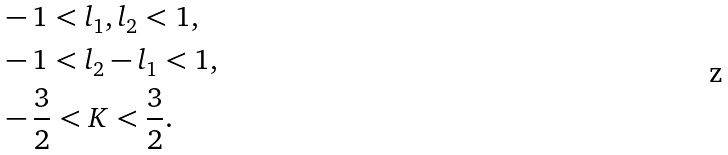Convert formula to latex. <formula><loc_0><loc_0><loc_500><loc_500>& - 1 < l _ { 1 } , l _ { 2 } < 1 , \\ & - 1 < l _ { 2 } - l _ { 1 } < 1 , \\ & - \frac { 3 } { 2 } < K < \frac { 3 } { 2 } .</formula> 